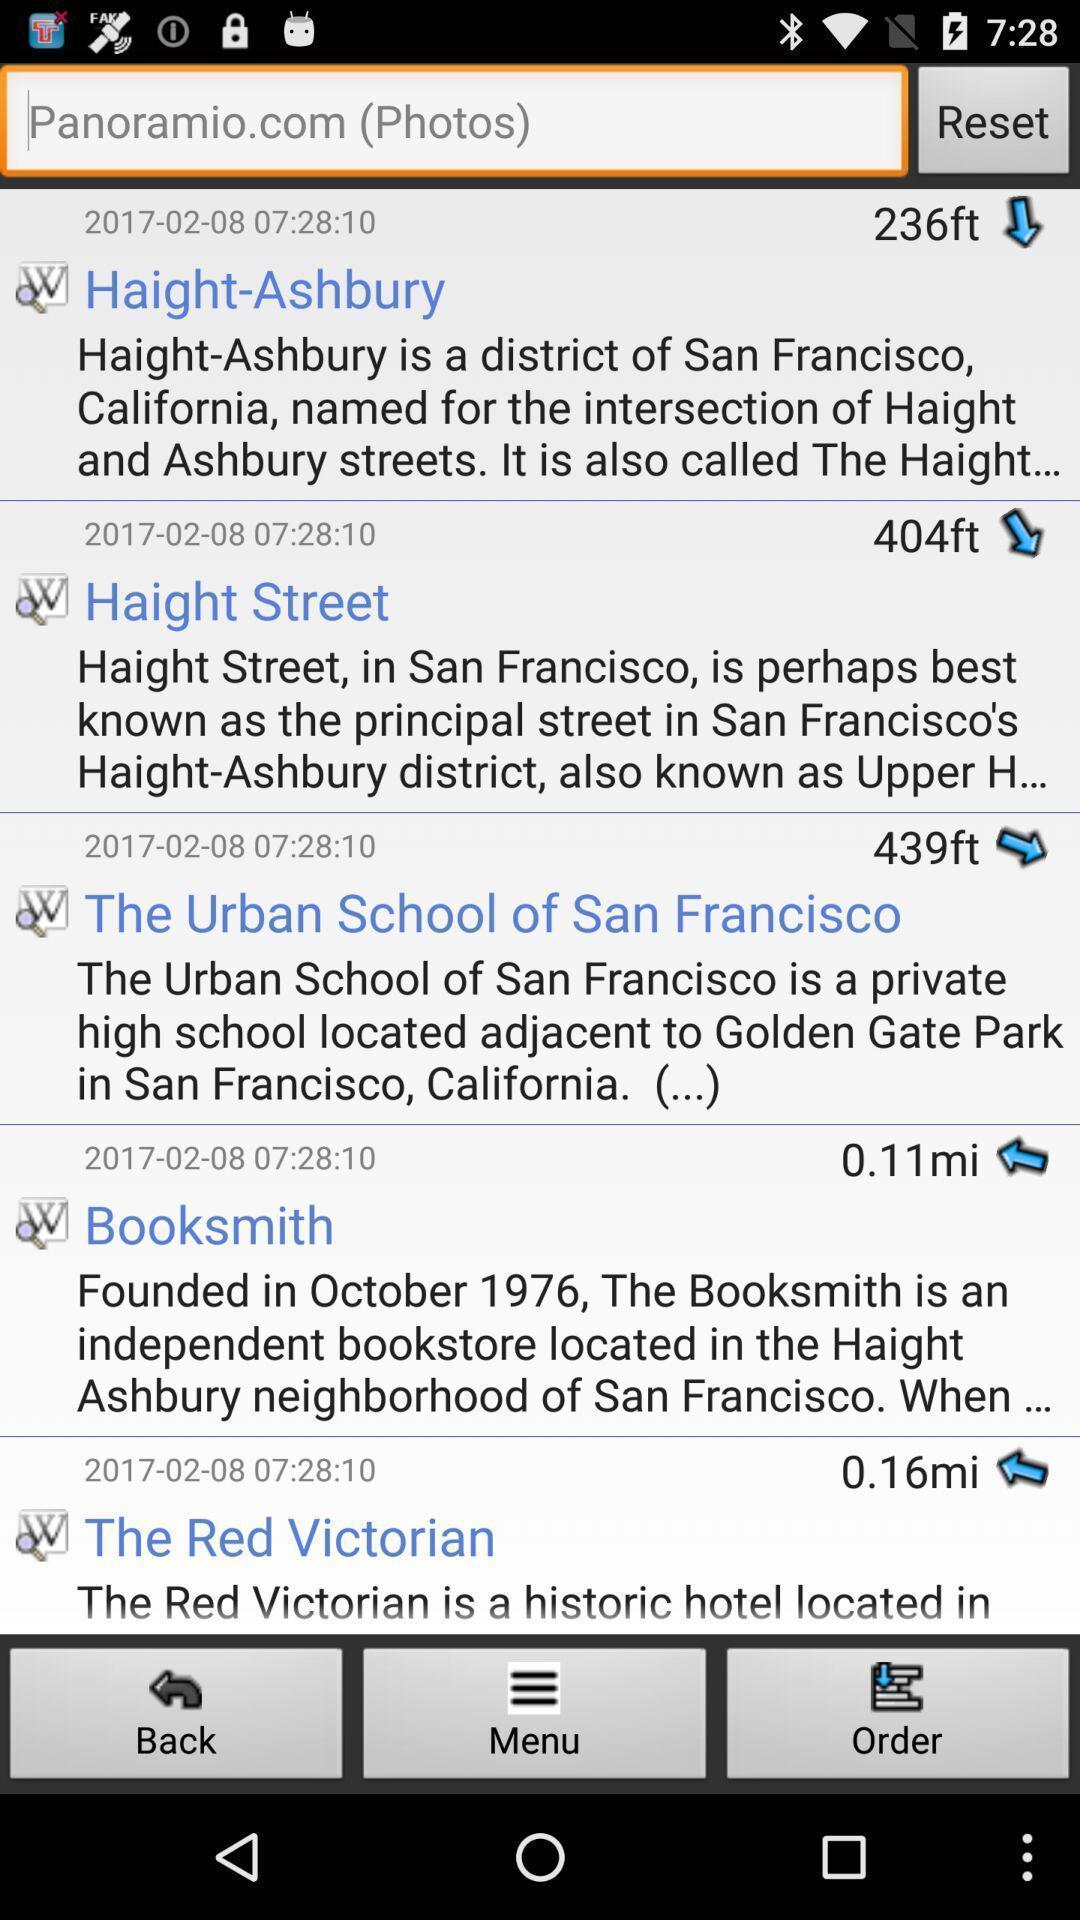Describe the visual elements of this screenshot. Page showing search results for locations. 